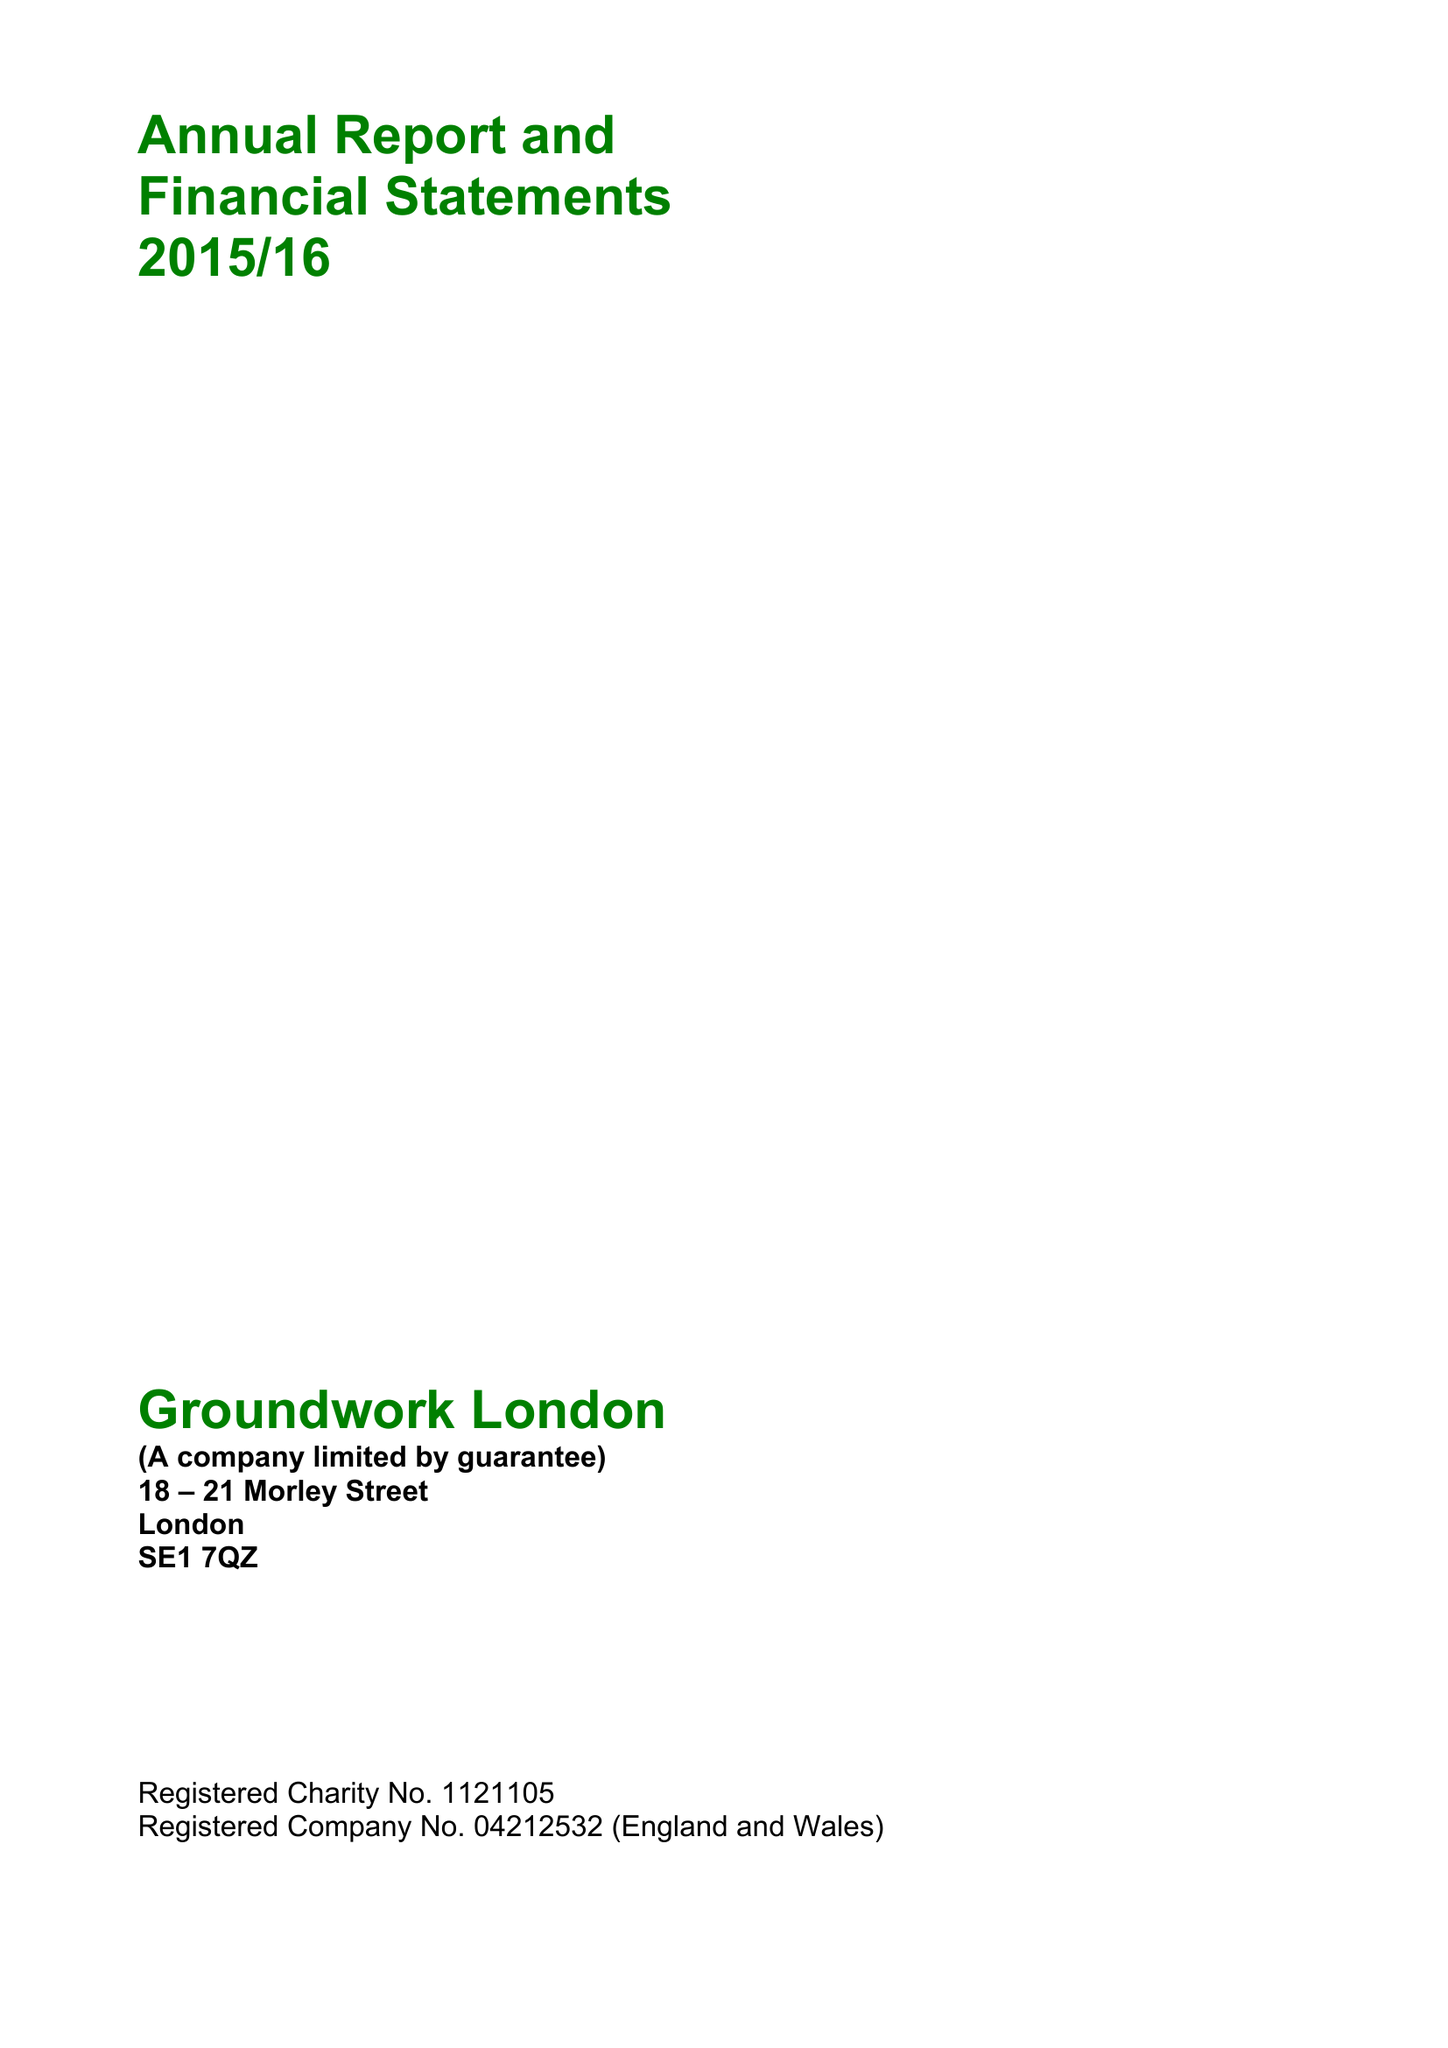What is the value for the report_date?
Answer the question using a single word or phrase. 2016-03-31 